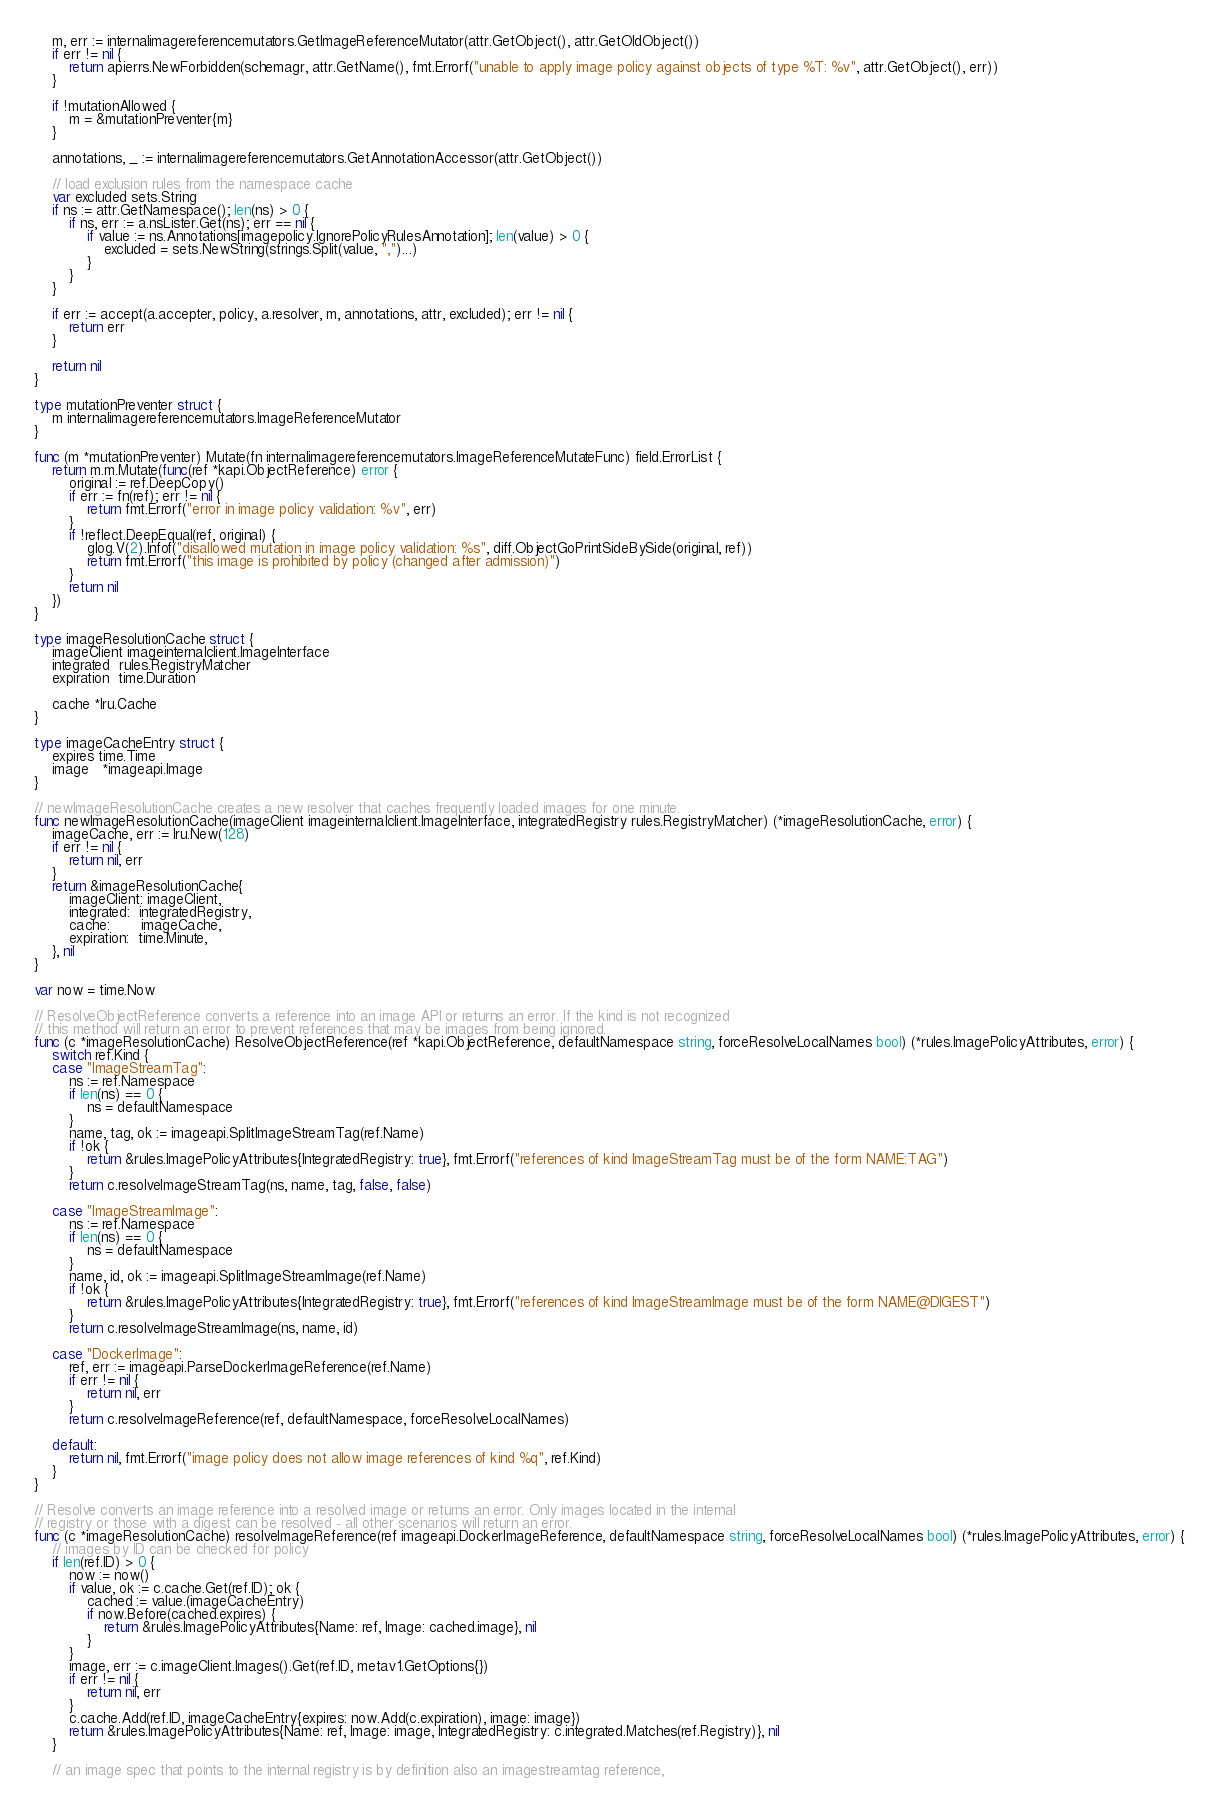<code> <loc_0><loc_0><loc_500><loc_500><_Go_>	m, err := internalimagereferencemutators.GetImageReferenceMutator(attr.GetObject(), attr.GetOldObject())
	if err != nil {
		return apierrs.NewForbidden(schemagr, attr.GetName(), fmt.Errorf("unable to apply image policy against objects of type %T: %v", attr.GetObject(), err))
	}

	if !mutationAllowed {
		m = &mutationPreventer{m}
	}

	annotations, _ := internalimagereferencemutators.GetAnnotationAccessor(attr.GetObject())

	// load exclusion rules from the namespace cache
	var excluded sets.String
	if ns := attr.GetNamespace(); len(ns) > 0 {
		if ns, err := a.nsLister.Get(ns); err == nil {
			if value := ns.Annotations[imagepolicy.IgnorePolicyRulesAnnotation]; len(value) > 0 {
				excluded = sets.NewString(strings.Split(value, ",")...)
			}
		}
	}

	if err := accept(a.accepter, policy, a.resolver, m, annotations, attr, excluded); err != nil {
		return err
	}

	return nil
}

type mutationPreventer struct {
	m internalimagereferencemutators.ImageReferenceMutator
}

func (m *mutationPreventer) Mutate(fn internalimagereferencemutators.ImageReferenceMutateFunc) field.ErrorList {
	return m.m.Mutate(func(ref *kapi.ObjectReference) error {
		original := ref.DeepCopy()
		if err := fn(ref); err != nil {
			return fmt.Errorf("error in image policy validation: %v", err)
		}
		if !reflect.DeepEqual(ref, original) {
			glog.V(2).Infof("disallowed mutation in image policy validation: %s", diff.ObjectGoPrintSideBySide(original, ref))
			return fmt.Errorf("this image is prohibited by policy (changed after admission)")
		}
		return nil
	})
}

type imageResolutionCache struct {
	imageClient imageinternalclient.ImageInterface
	integrated  rules.RegistryMatcher
	expiration  time.Duration

	cache *lru.Cache
}

type imageCacheEntry struct {
	expires time.Time
	image   *imageapi.Image
}

// newImageResolutionCache creates a new resolver that caches frequently loaded images for one minute.
func newImageResolutionCache(imageClient imageinternalclient.ImageInterface, integratedRegistry rules.RegistryMatcher) (*imageResolutionCache, error) {
	imageCache, err := lru.New(128)
	if err != nil {
		return nil, err
	}
	return &imageResolutionCache{
		imageClient: imageClient,
		integrated:  integratedRegistry,
		cache:       imageCache,
		expiration:  time.Minute,
	}, nil
}

var now = time.Now

// ResolveObjectReference converts a reference into an image API or returns an error. If the kind is not recognized
// this method will return an error to prevent references that may be images from being ignored.
func (c *imageResolutionCache) ResolveObjectReference(ref *kapi.ObjectReference, defaultNamespace string, forceResolveLocalNames bool) (*rules.ImagePolicyAttributes, error) {
	switch ref.Kind {
	case "ImageStreamTag":
		ns := ref.Namespace
		if len(ns) == 0 {
			ns = defaultNamespace
		}
		name, tag, ok := imageapi.SplitImageStreamTag(ref.Name)
		if !ok {
			return &rules.ImagePolicyAttributes{IntegratedRegistry: true}, fmt.Errorf("references of kind ImageStreamTag must be of the form NAME:TAG")
		}
		return c.resolveImageStreamTag(ns, name, tag, false, false)

	case "ImageStreamImage":
		ns := ref.Namespace
		if len(ns) == 0 {
			ns = defaultNamespace
		}
		name, id, ok := imageapi.SplitImageStreamImage(ref.Name)
		if !ok {
			return &rules.ImagePolicyAttributes{IntegratedRegistry: true}, fmt.Errorf("references of kind ImageStreamImage must be of the form NAME@DIGEST")
		}
		return c.resolveImageStreamImage(ns, name, id)

	case "DockerImage":
		ref, err := imageapi.ParseDockerImageReference(ref.Name)
		if err != nil {
			return nil, err
		}
		return c.resolveImageReference(ref, defaultNamespace, forceResolveLocalNames)

	default:
		return nil, fmt.Errorf("image policy does not allow image references of kind %q", ref.Kind)
	}
}

// Resolve converts an image reference into a resolved image or returns an error. Only images located in the internal
// registry or those with a digest can be resolved - all other scenarios will return an error.
func (c *imageResolutionCache) resolveImageReference(ref imageapi.DockerImageReference, defaultNamespace string, forceResolveLocalNames bool) (*rules.ImagePolicyAttributes, error) {
	// images by ID can be checked for policy
	if len(ref.ID) > 0 {
		now := now()
		if value, ok := c.cache.Get(ref.ID); ok {
			cached := value.(imageCacheEntry)
			if now.Before(cached.expires) {
				return &rules.ImagePolicyAttributes{Name: ref, Image: cached.image}, nil
			}
		}
		image, err := c.imageClient.Images().Get(ref.ID, metav1.GetOptions{})
		if err != nil {
			return nil, err
		}
		c.cache.Add(ref.ID, imageCacheEntry{expires: now.Add(c.expiration), image: image})
		return &rules.ImagePolicyAttributes{Name: ref, Image: image, IntegratedRegistry: c.integrated.Matches(ref.Registry)}, nil
	}

	// an image spec that points to the internal registry is by definition also an imagestreamtag reference,</code> 